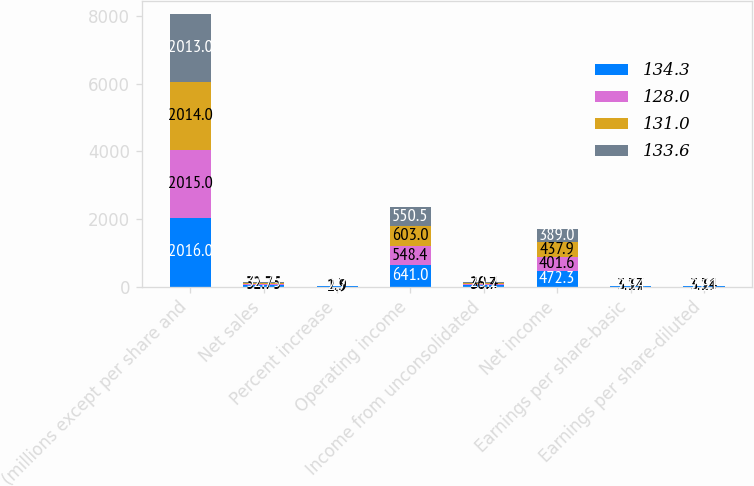Convert chart. <chart><loc_0><loc_0><loc_500><loc_500><stacked_bar_chart><ecel><fcel>(millions except per share and<fcel>Net sales<fcel>Percent increase<fcel>Operating income<fcel>Income from unconsolidated<fcel>Net income<fcel>Earnings per share-basic<fcel>Earnings per share-diluted<nl><fcel>134.3<fcel>2016<fcel>32.75<fcel>2.7<fcel>641<fcel>36.1<fcel>472.3<fcel>3.73<fcel>3.69<nl><fcel>128<fcel>2015<fcel>32.75<fcel>1.3<fcel>548.4<fcel>36.7<fcel>401.6<fcel>3.14<fcel>3.11<nl><fcel>131<fcel>2014<fcel>32.75<fcel>2.9<fcel>603<fcel>29.4<fcel>437.9<fcel>3.37<fcel>3.34<nl><fcel>133.6<fcel>2013<fcel>32.75<fcel>2.7<fcel>550.5<fcel>23.2<fcel>389<fcel>2.94<fcel>2.91<nl></chart> 